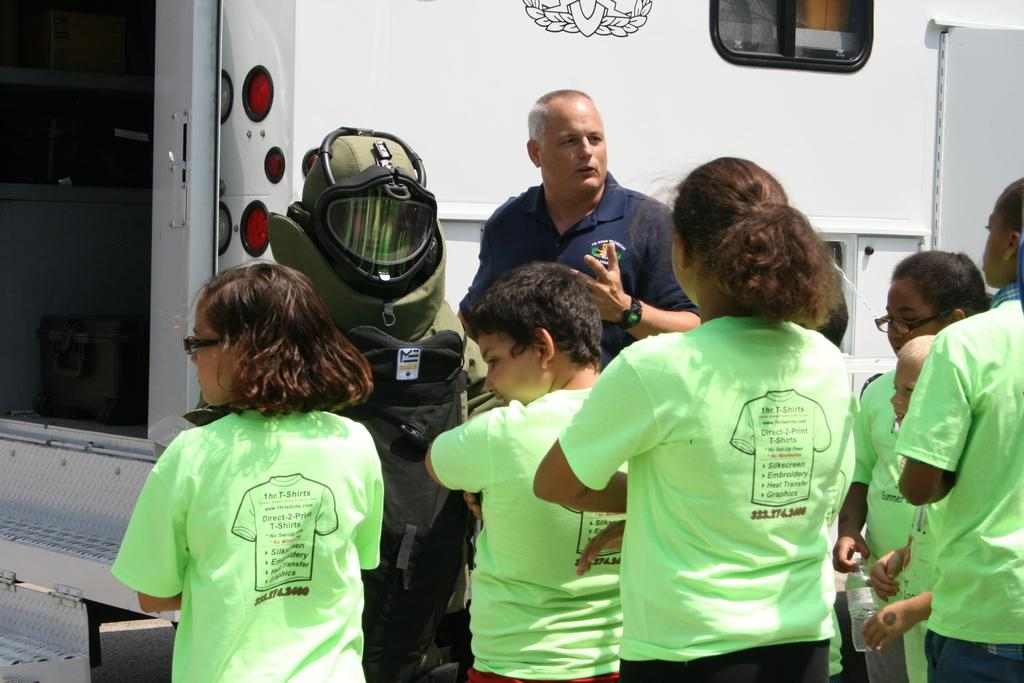What is happening in the center of the image? There is a group of persons standing on the road in the center of the image. What can be seen on the left side of the image? There is a suit and a girl on the left side of the image. Can you describe the background of the image? There is a vehicle visible in the background of the image. What type of cart is being blown by the wind in the image? There is no cart present in the image, nor is there any wind blowing anything. 